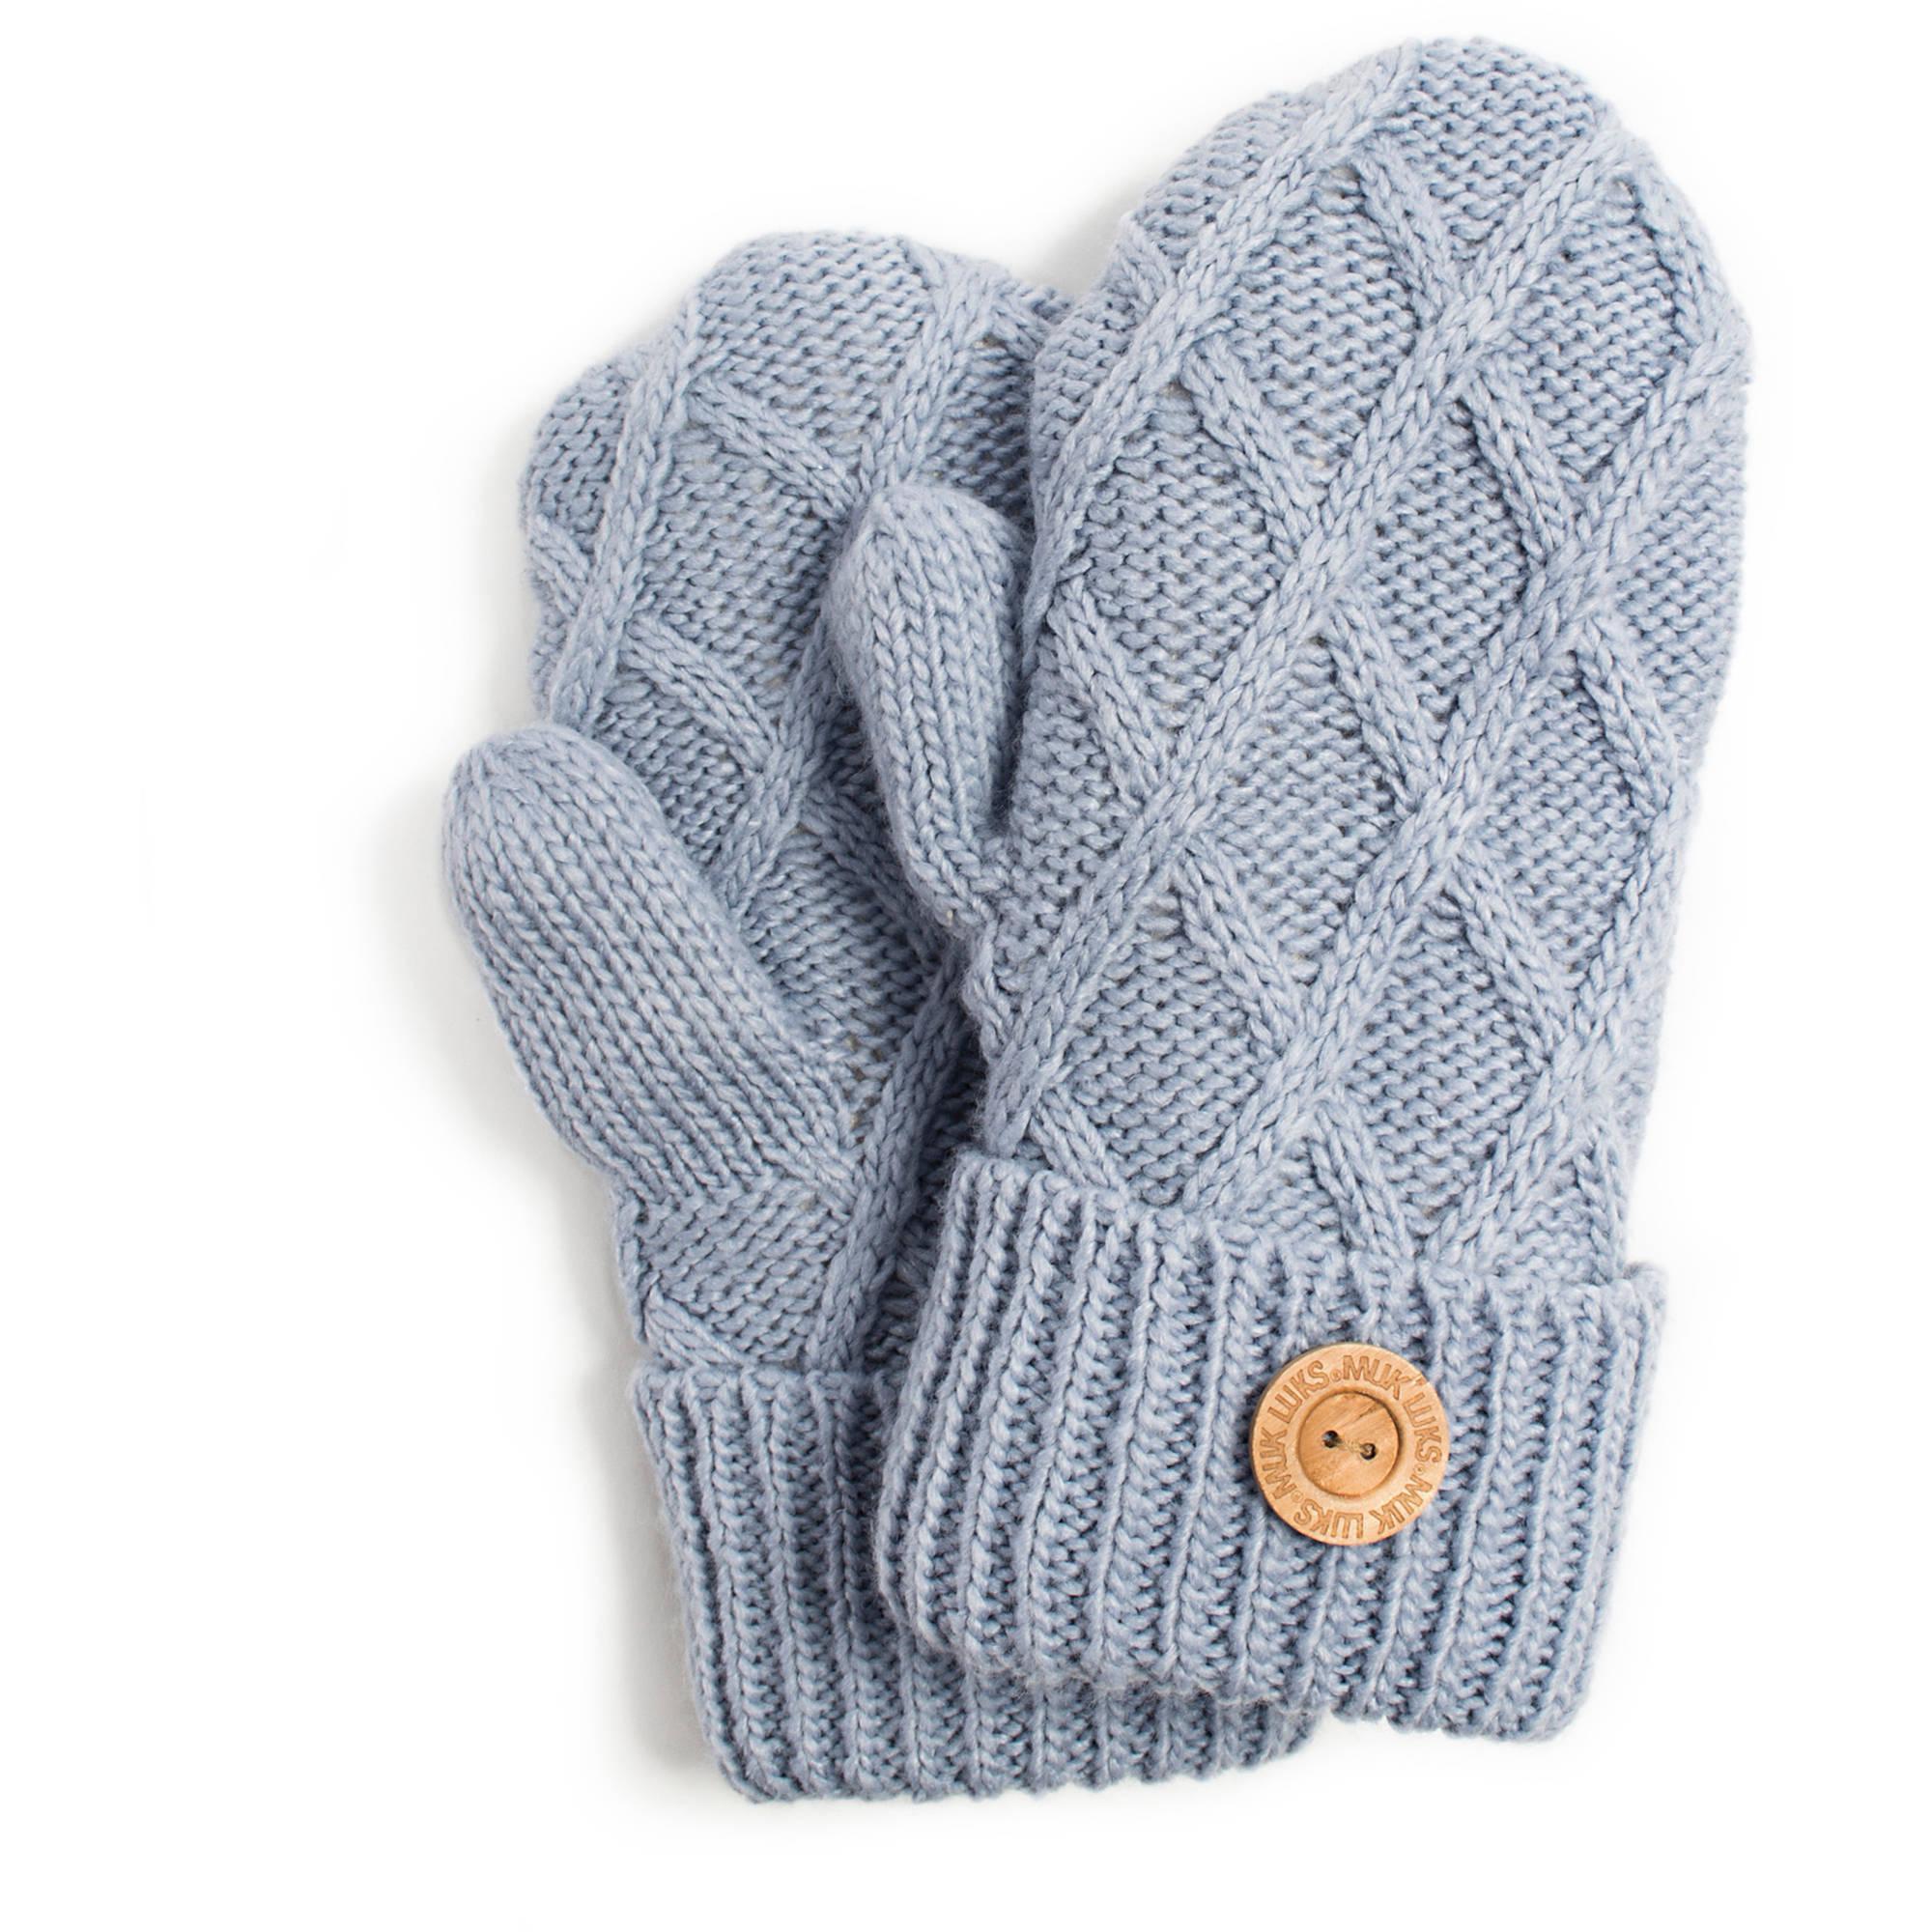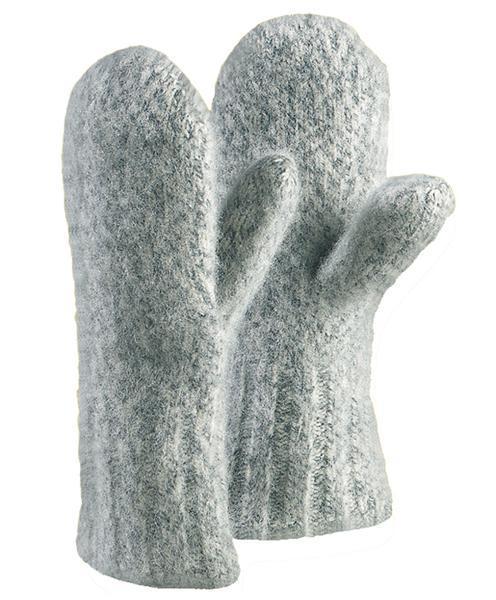The first image is the image on the left, the second image is the image on the right. Assess this claim about the two images: "One pair of gloves is dark grey.". Correct or not? Answer yes or no. No. The first image is the image on the left, the second image is the image on the right. Given the left and right images, does the statement "All mittens shown have rounded tops without fingers, and the knitted mitten pair on the left is a solid color with a diamond pattern." hold true? Answer yes or no. Yes. 